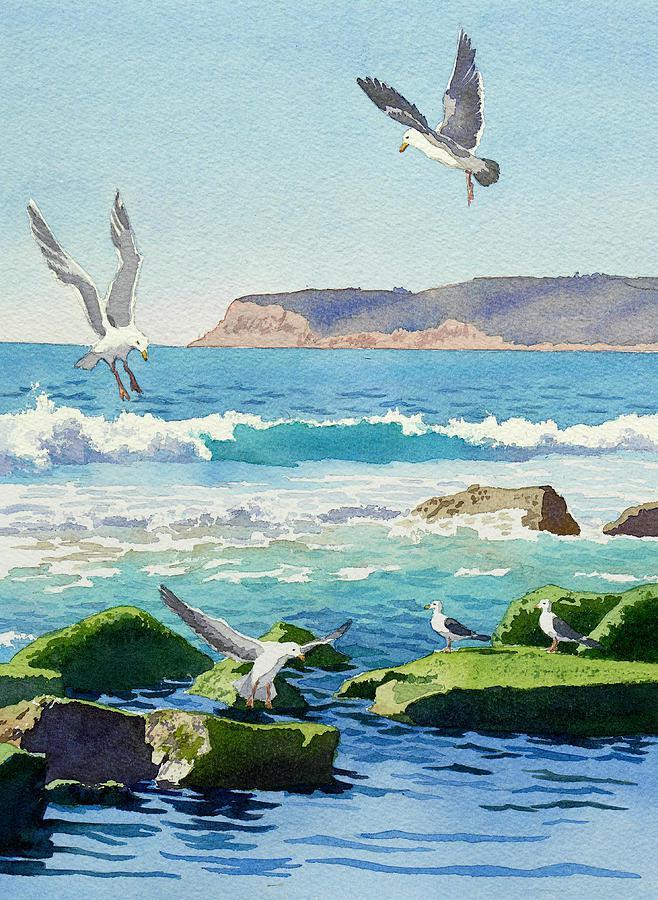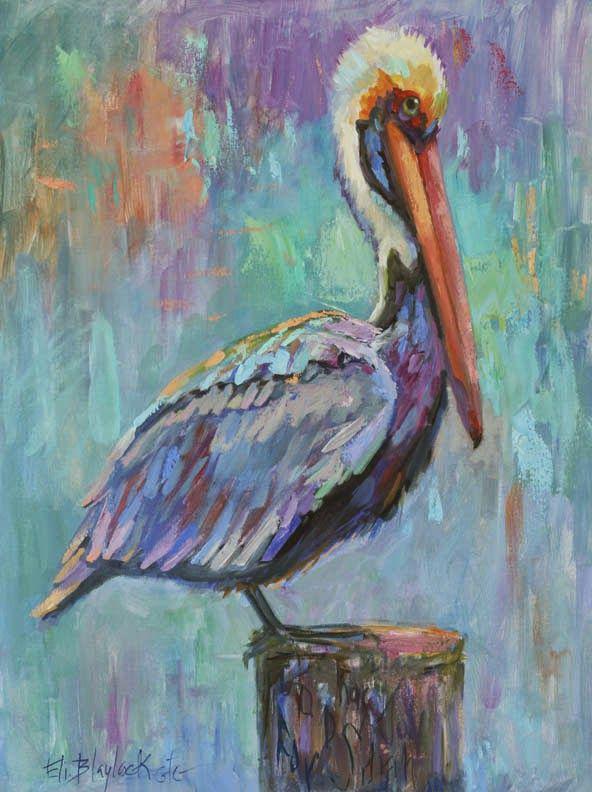The first image is the image on the left, the second image is the image on the right. Considering the images on both sides, is "One image includes a pelican and a smaller seabird perched on some part of a wooden pier." valid? Answer yes or no. No. The first image is the image on the left, the second image is the image on the right. Examine the images to the left and right. Is the description "A single pelican sits on a post in one of the image." accurate? Answer yes or no. Yes. 